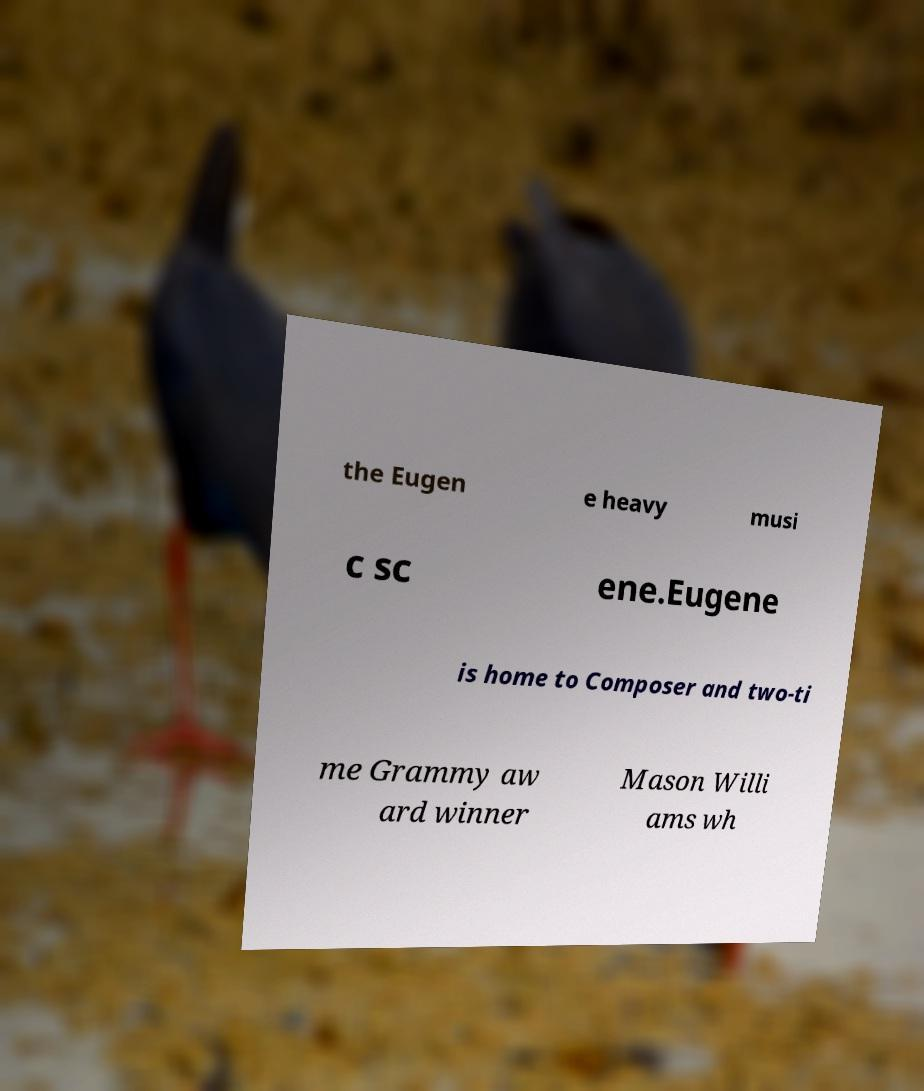Could you assist in decoding the text presented in this image and type it out clearly? the Eugen e heavy musi c sc ene.Eugene is home to Composer and two-ti me Grammy aw ard winner Mason Willi ams wh 